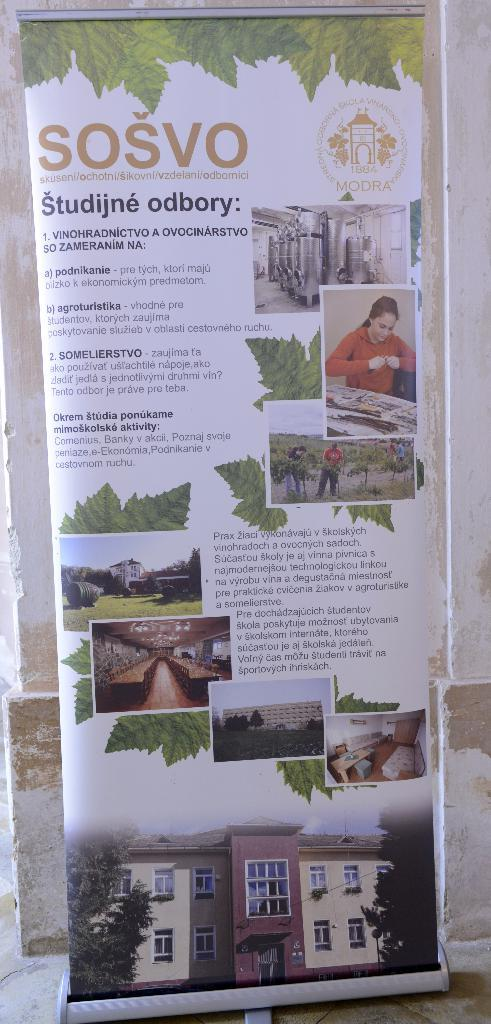What is the main object in the center of the image? There is a board in the center of the image. What can be seen on the board? There is text on the board. Can you describe the people in the image? There are persons in the image. What type of natural elements are present in the image? There are trees in the image. What type of man-made structures can be seen in the image? There are buildings in the image. What other objects are visible in the image? There are some objects in the image. What can be seen in the background of the image? There is a wall visible in the background of the image. Can you tell me how the visitor is being helped in the image? There is no visitor present in the image, and therefore, no help being provided. 